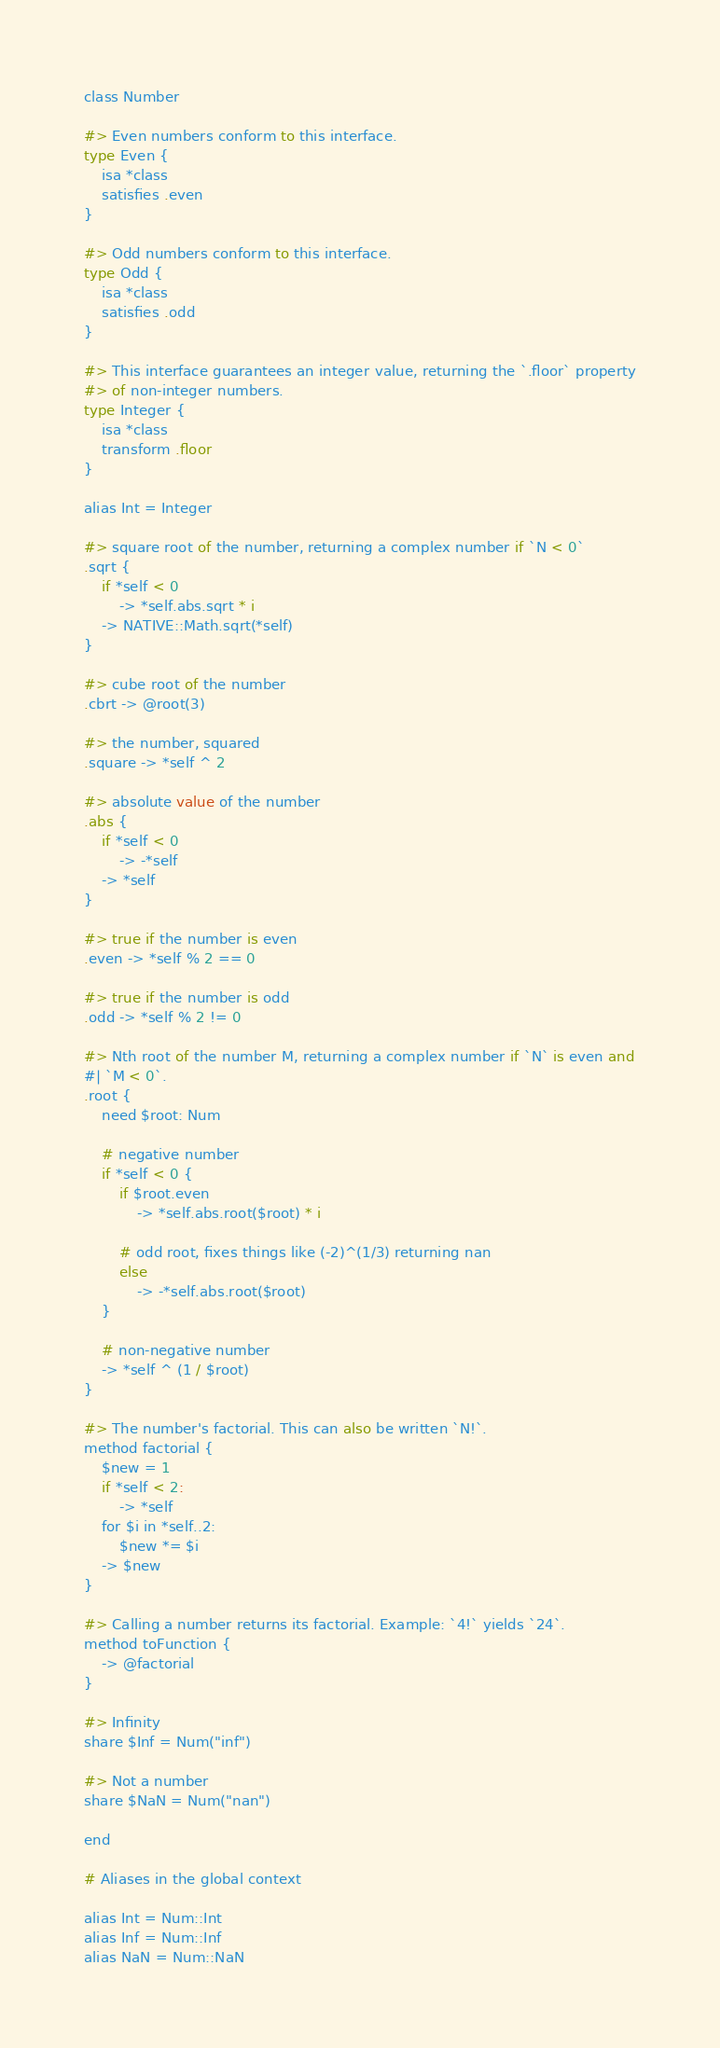Convert code to text. <code><loc_0><loc_0><loc_500><loc_500><_Forth_>class Number

#> Even numbers conform to this interface.
type Even {
    isa *class
    satisfies .even
}

#> Odd numbers conform to this interface.
type Odd {
    isa *class
    satisfies .odd
}

#> This interface guarantees an integer value, returning the `.floor` property
#> of non-integer numbers.
type Integer {
    isa *class
    transform .floor
}

alias Int = Integer

#> square root of the number, returning a complex number if `N < 0`
.sqrt {
    if *self < 0
        -> *self.abs.sqrt * i
    -> NATIVE::Math.sqrt(*self)
}

#> cube root of the number
.cbrt -> @root(3)

#> the number, squared
.square -> *self ^ 2

#> absolute value of the number
.abs {
    if *self < 0
        -> -*self
    -> *self
}

#> true if the number is even
.even -> *self % 2 == 0

#> true if the number is odd
.odd -> *self % 2 != 0

#> Nth root of the number M, returning a complex number if `N` is even and
#| `M < 0`.
.root {
    need $root: Num
    
    # negative number
    if *self < 0 {
        if $root.even
            -> *self.abs.root($root) * i
            
        # odd root, fixes things like (-2)^(1/3) returning nan
        else
            -> -*self.abs.root($root)
    }
    
    # non-negative number
    -> *self ^ (1 / $root)
}

#> The number's factorial. This can also be written `N!`.
method factorial {
    $new = 1
    if *self < 2:
        -> *self
    for $i in *self..2:
        $new *= $i
    -> $new
}

#> Calling a number returns its factorial. Example: `4!` yields `24`.
method toFunction {
    -> @factorial
}

#> Infinity
share $Inf = Num("inf")

#> Not a number
share $NaN = Num("nan")

end

# Aliases in the global context

alias Int = Num::Int
alias Inf = Num::Inf
alias NaN = Num::NaN
</code> 